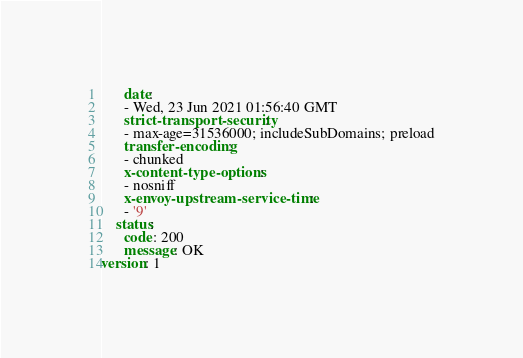Convert code to text. <code><loc_0><loc_0><loc_500><loc_500><_YAML_>      date:
      - Wed, 23 Jun 2021 01:56:40 GMT
      strict-transport-security:
      - max-age=31536000; includeSubDomains; preload
      transfer-encoding:
      - chunked
      x-content-type-options:
      - nosniff
      x-envoy-upstream-service-time:
      - '9'
    status:
      code: 200
      message: OK
version: 1
</code> 